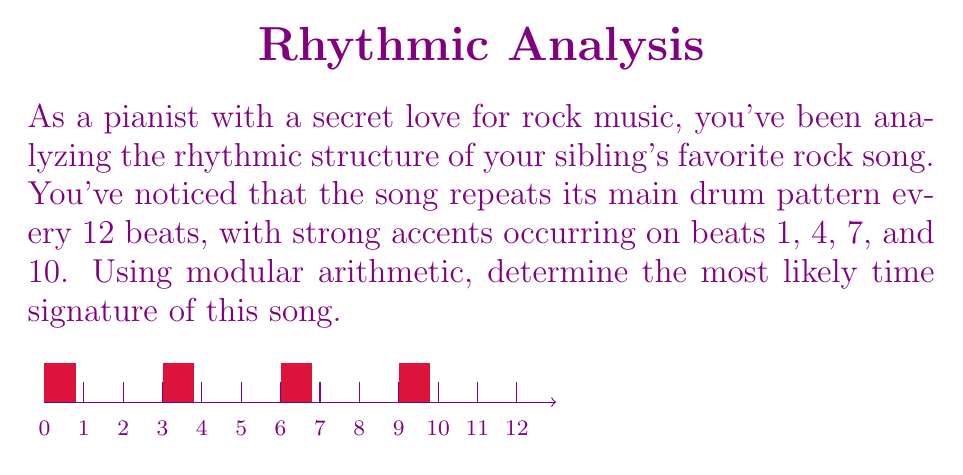Provide a solution to this math problem. Let's approach this step-by-step using modular arithmetic:

1) The song repeats every 12 beats, so we're working in mod 12.

2) The strong accents occur on beats 1, 4, 7, and 10. In modular arithmetic, this can be expressed as:
   $1 \equiv 4 \equiv 7 \equiv 10 \pmod{3}$

3) This suggests that the time signature is likely to have 3 beats per measure, as the accents occur every 3 beats.

4) To confirm, let's check if 12 (the total number of beats in the pattern) is divisible by 3:
   $12 \div 3 = 4$

5) This means we can fit 4 measures of 3 beats each within the 12-beat pattern.

6) In rock music, the most common time signature with 3 beats per measure is 3/4.

7) To verify, let's count the accents:
   Measure 1: beat 1 (accent)
   Measure 2: beat 4 (accent)
   Measure 3: beat 7 (accent)
   Measure 4: beat 10 (accent)

8) This perfectly matches our original accent pattern.

Therefore, based on the modular arithmetic analysis of the accent pattern, the most likely time signature for this rock song is 3/4.
Answer: 3/4 